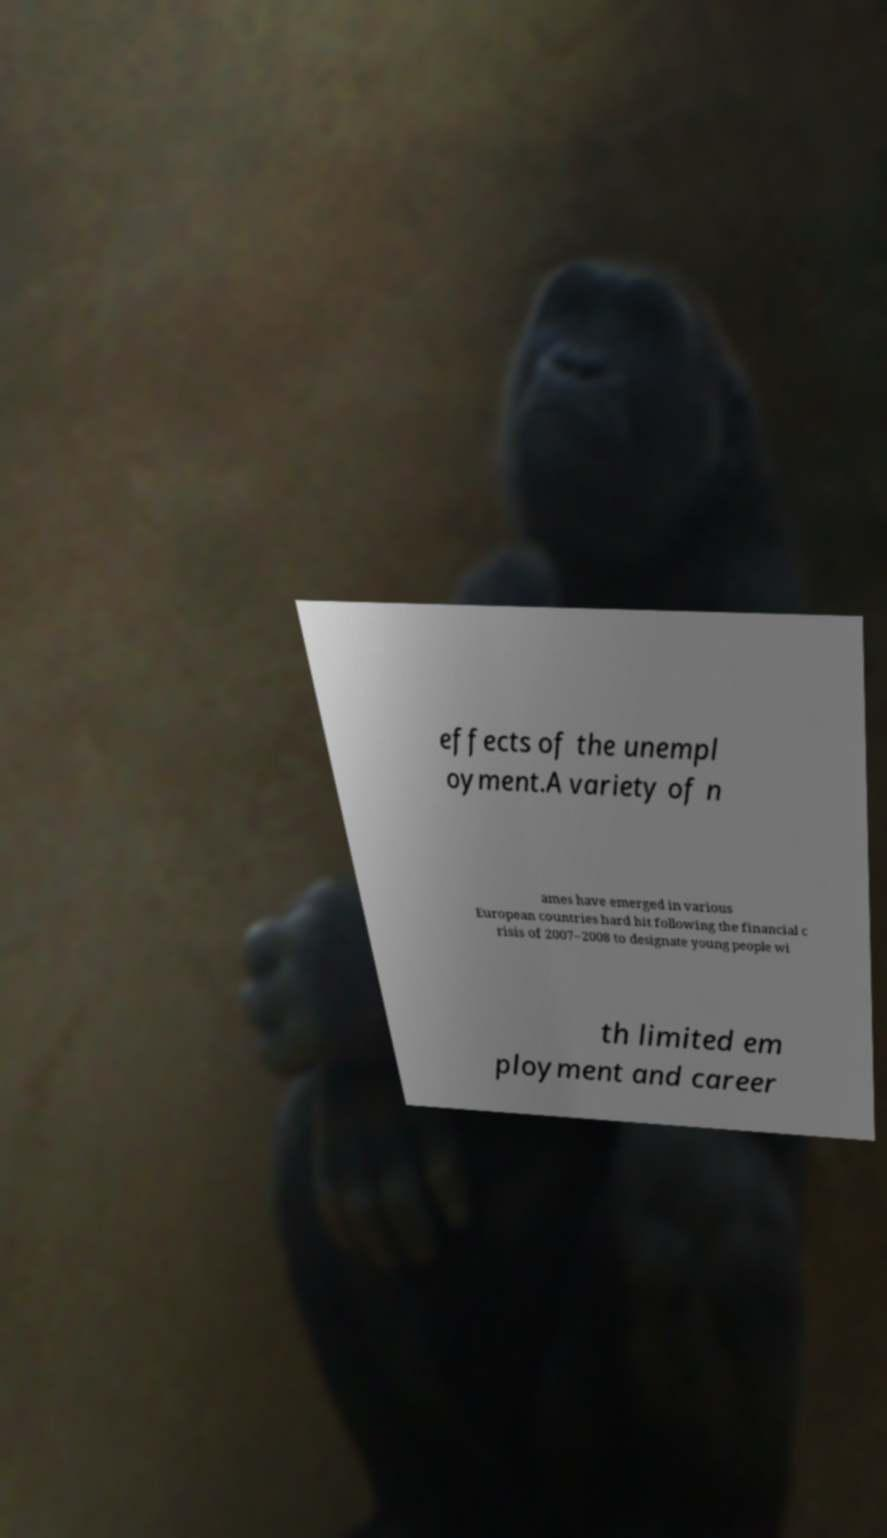Can you read and provide the text displayed in the image?This photo seems to have some interesting text. Can you extract and type it out for me? effects of the unempl oyment.A variety of n ames have emerged in various European countries hard hit following the financial c risis of 2007–2008 to designate young people wi th limited em ployment and career 